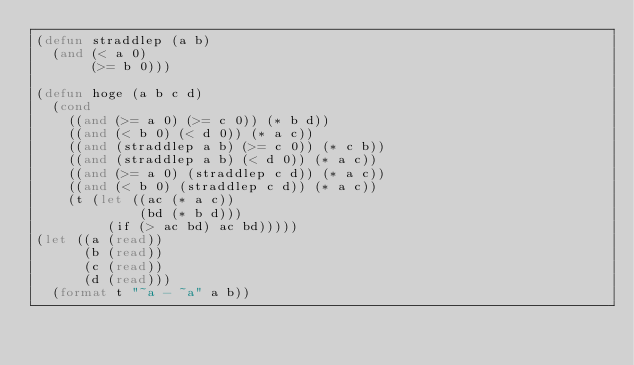<code> <loc_0><loc_0><loc_500><loc_500><_Lisp_>(defun straddlep (a b)
  (and (< a 0)
       (>= b 0)))

(defun hoge (a b c d)
  (cond
    ((and (>= a 0) (>= c 0)) (* b d))
    ((and (< b 0) (< d 0)) (* a c))
    ((and (straddlep a b) (>= c 0)) (* c b))
    ((and (straddlep a b) (< d 0)) (* a c))
    ((and (>= a 0) (straddlep c d)) (* a c))
    ((and (< b 0) (straddlep c d)) (* a c))
    (t (let ((ac (* a c))
             (bd (* b d)))
         (if (> ac bd) ac bd)))))
(let ((a (read))
      (b (read))
      (c (read))
      (d (read)))
  (format t "~a - ~a" a b))
</code> 